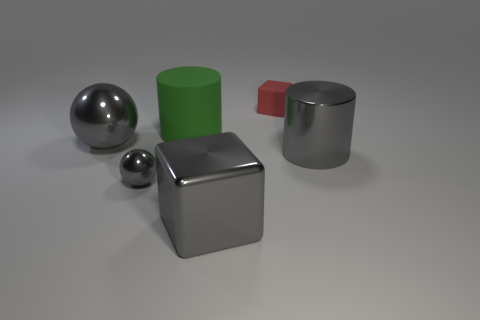What number of big purple rubber things are the same shape as the green thing?
Ensure brevity in your answer.  0. There is a big sphere that is the same color as the shiny block; what is its material?
Your answer should be compact. Metal. What number of tiny gray metallic spheres are there?
Provide a short and direct response. 1. There is a red object; is its shape the same as the big metal thing that is right of the small rubber object?
Keep it short and to the point. No. How many objects are tiny purple rubber cylinders or big gray objects that are right of the large gray sphere?
Give a very brief answer. 2. There is another big thing that is the same shape as the red matte object; what is its material?
Your response must be concise. Metal. Do the tiny object on the left side of the green cylinder and the red thing have the same shape?
Give a very brief answer. No. Are there any other things that are the same size as the green cylinder?
Make the answer very short. Yes. Are there fewer gray shiny objects that are in front of the tiny shiny object than large gray metallic spheres on the right side of the big green thing?
Provide a succinct answer. No. What number of other objects are the same shape as the small metallic thing?
Your answer should be very brief. 1. 